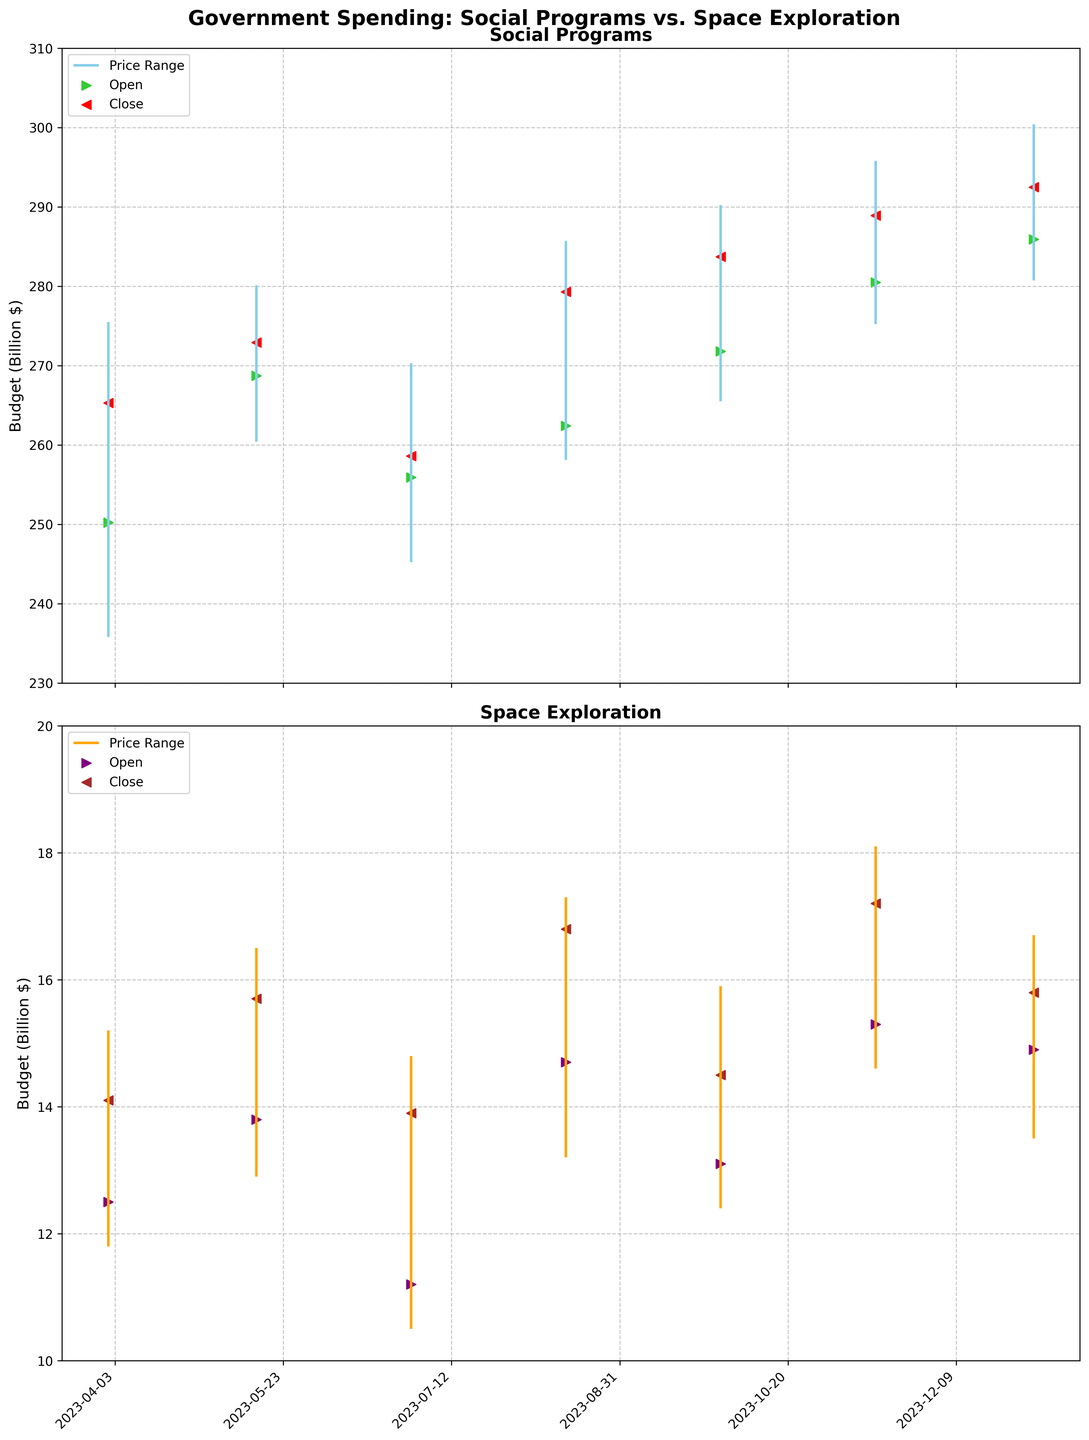Which category has a higher final budget on 2023-04-01? To find the answer, compare the closing values of Social Security ($265.3 billion) and NASA Budget ($14.1 billion) on 2023-04-01. Social Security has a higher final budget.
Answer: Social Security What is the budget range for Medicare on 2023-05-15? The budget range can be found by subtracting the Low value from the High value for Medicare on 2023-05-15. The range is 280.1 - 260.4 = $19.7 billion.
Answer: $19.7 billion How does the budget fluctuation of Food Stamps compare to ESA Collaboration on 2023-06-30? Food Stamps has a High of 270.3 and a Low of 245.2, resulting in a fluctuation range of 270.3 - 245.2 = $25.1 billion. ESA Collaboration has a High of 14.8 and a Low of 10.5, resulting in a fluctuation range of 14.8 - 10.5 = $4.3 billion. Therefore, Food Stamps fluctuates more.
Answer: Food Stamps has a larger fluctuation What is the overall trend for the social programs' final budgets throughout the fiscal year? By examining the Close values for social programs over time: Social Security ($265.3 billion), Medicare ($272.9 billion), Food Stamps ($258.6 billion), Medicaid ($279.3 billion), Education Grants ($283.7 billion), Veterans Affairs ($288.9 billion), and Housing Assistance ($292.5 billion), we observe an overall increasing trend in the final budgets.
Answer: Increasing trend Which space exploration initiative had the highest budget in its category, and how much was it? By examining all High values for space exploration initiatives, Mars Exploration on 2023-08-15 had the highest budget with a High value of $17.3 billion.
Answer: Mars Exploration, $17.3 billion How much more was the closing budget of Housing Assistance on 2024-01-01 compared to the closing budget of Space Station Maintenance on the same date? Compare the Close values of Housing Assistance ($292.5 billion) and Space Station Maintenance ($15.8 billion) on 2024-01-01, then subtract the latter from the former. $292.5 billion - $15.8 billion = $276.7 billion.
Answer: $276.7 billion What are the notable differences between the characteristics of fluctuations in social programs and space exploration budgets? Social programs demonstrate higher overall values, larger ranges, and a more pronounced upward trend over time. Space exploration budgets are lower in value, have smaller ranges, and exhibit less noticeable trends. For instance, the fluctuation range for social programs can be as high as $60.6 billion for Veterans Affairs, whereas for space initiatives like ESA Collaboration, it is as low as $4.3 billion.
Answer: Higher values & ranges in social programs During which date range did the Medicaid program show the highest budget levels among social programs, and what was the peak High value? Medicaid's highest budget levels can be observed from its High value on 2023-08-15. The peak High value for Medicaid was $285.7 billion.
Answer: 2023-08-15, $285.7 billion Which program had the lowest budget close value in the data set, and what was the value? The lowest closing budget in the dataset belongs to the NASA Budget on 2023-04-01 with a Close value of $14.1 billion.
Answer: NASA Budget, $14.1 billion 